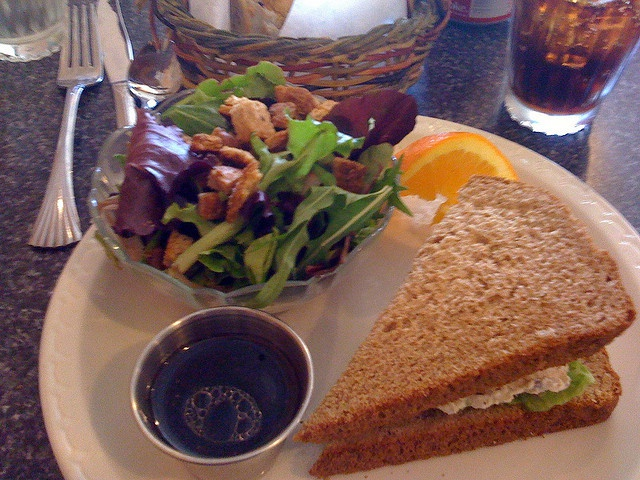Describe the objects in this image and their specific colors. I can see sandwich in gray, salmon, maroon, brown, and tan tones, bowl in gray, purple, and lavender tones, bowl in gray, black, and maroon tones, cup in gray, navy, purple, and brown tones, and bowl in gray, olive, and maroon tones in this image. 